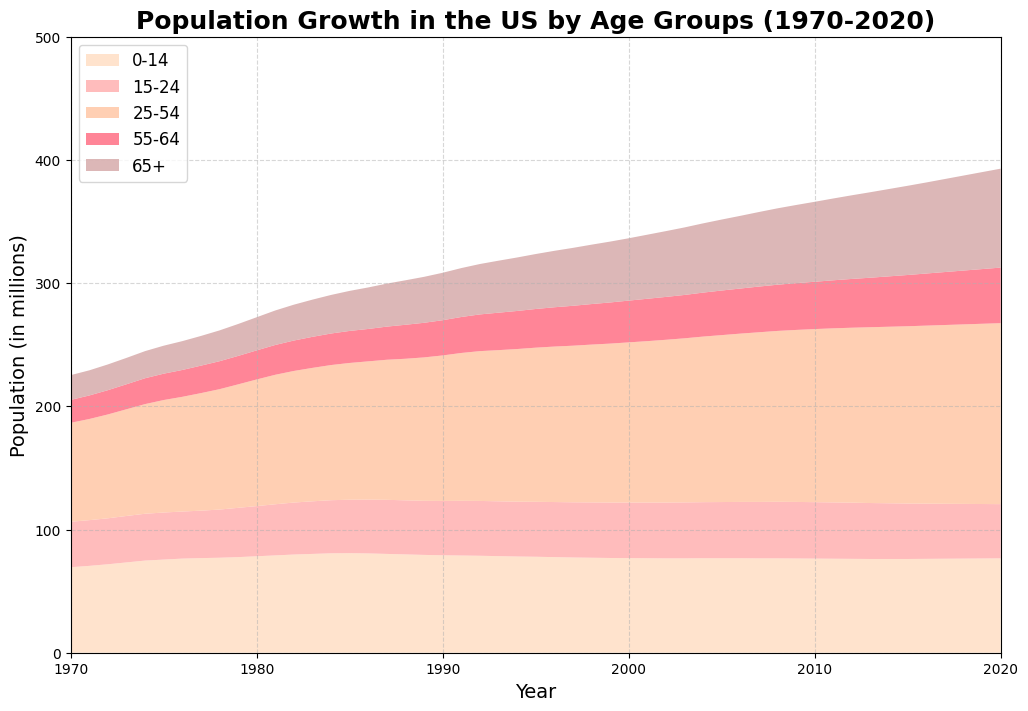What is the sum of the population for all age groups in the year 2020? First, note the values for each age group in 2020: 76.6 (0-14), 44.0 (15-24), 146.9 (25-54), 45.1 (55-64), and 80.3 (65+). Sum these values: 76.6 + 44.0 + 146.9 + 45.1 + 80.3 = 392.9
Answer: 392.9 Which age group experienced the greatest increase in population from 1970 to 2020? Compare the population differences for each group: 0-14 (76.6-69.4=7.2), 15-24 (44.0-36.9=7.1), 25-54 (146.9-80.3=66.6), 55-64 (45.1-18.6=26.5), 65+ (80.3-20.1=60.2). The 25-54 age group had the greatest increase.
Answer: 25-54 What was the population trend for the 0-14 age group over the 50 years? Looking at the area chart, the 0-14 age group population increased slightly from 69.4 million in 1970 to around 77 million in the mid-1980s, and then gradually decreased to 76.6 million by 2020.
Answer: Slight Increase, then Decrease In which year did the population for the 65+ age group surpass 50 million? Identify the first year the 65+ group’s area crossed the 50 million mark. Observing the chart, this happens around the year 2000.
Answer: 2000 How does the population of the 15-24 age group in 1990 compare to the population in 2020? Check the population values: 44.1 million in 1990 and 44.0 million in 2020. The values are almost equal, with a slight decrease of 0.1 million in 2020.
Answer: Slightly Decreased What visual pattern do you see in the population of the 25-54 age group from 1970 to 2020? The 25-54 age group shows a steady increase in population throughout the 50 years, representing a growing segment of the population consistently over time.
Answer: Steady Increase By how much did the total population of the 55-64 age group increase between 1975 and 2020? Note the populations in 1975 (21.4 million) and 2020 (45.1 million). Subtract the 1975 value from the 2020 value: 45.1 - 21.4 = 23.7 million.
Answer: 23.7 During which decade did the 0-14 age group see the most significant decrease in population? Identify the decade showing the largest drop for 0-14 group. The largest decrease happens between the mid-1980s and the early 1990s.
Answer: 1980s to 1990s Compare the growth rate of the population in the 65+ age group from 1980 to 2000 with the growth rate from 2000 to 2020. For 1980-2000: (50.6-26.9)/26.9 ≈ 88%; For 2000-2020: (80.3-50.6)/50.6 ≈ 58%. The 1980 to 2000 growth rate was higher compared to 2000 to 2020.
Answer: Higher from 1980 to 2000 Which age group had the least variation in its population over the 50 years? Observing the areas of each group, the 15-24 age group appears to have the least change in its population over the years.
Answer: 15-24 